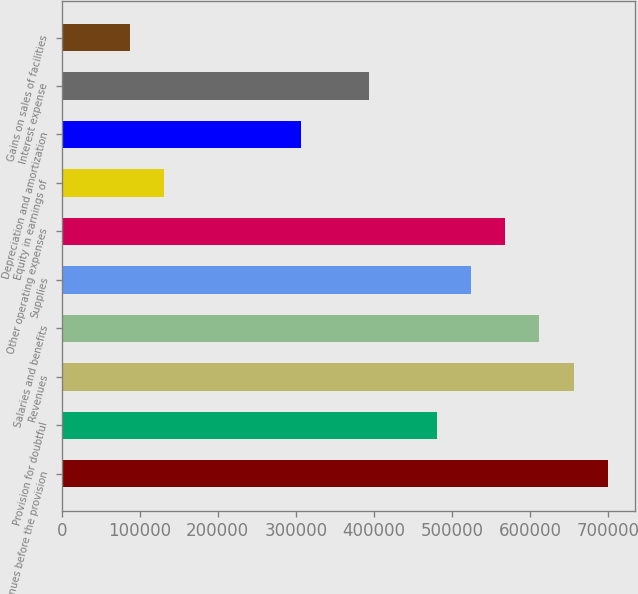<chart> <loc_0><loc_0><loc_500><loc_500><bar_chart><fcel>Revenues before the provision<fcel>Provision for doubtful<fcel>Revenues<fcel>Salaries and benefits<fcel>Supplies<fcel>Other operating expenses<fcel>Equity in earnings of<fcel>Depreciation and amortization<fcel>Interest expense<fcel>Gains on sales of facilities<nl><fcel>699753<fcel>481081<fcel>656019<fcel>612285<fcel>524816<fcel>568550<fcel>131206<fcel>306144<fcel>393613<fcel>87471.6<nl></chart> 